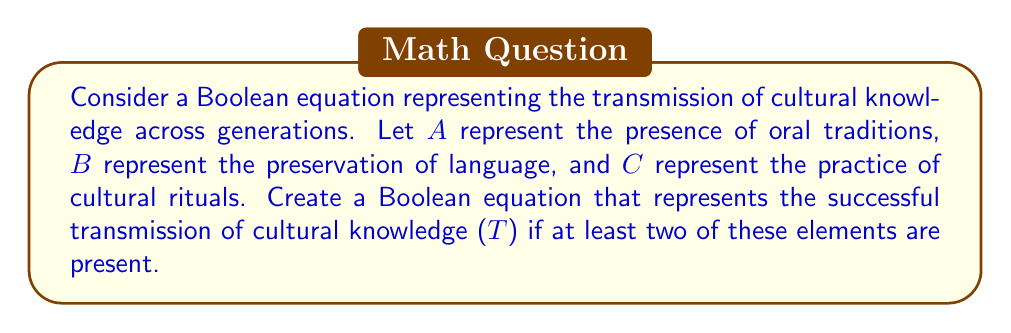What is the answer to this math problem? To solve this problem, we need to create a Boolean equation that represents the successful transmission of cultural knowledge when at least two out of three elements are present. We can approach this step-by-step:

1. First, let's consider the combinations where at least two elements are present:
   - $A$ and $B$ are present: $A \cdot B$
   - $A$ and $C$ are present: $A \cdot C$
   - $B$ and $C$ are present: $B \cdot C$
   - All three ($A$, $B$, and $C$) are present: $A \cdot B \cdot C$

2. We can combine these situations using the OR operator ($+$) since any of these combinations would result in successful transmission:

   $T = (A \cdot B) + (A \cdot C) + (B \cdot C) + (A \cdot B \cdot C)$

3. However, we can simplify this equation further. Notice that the term $(A \cdot B \cdot C)$ is redundant because it's already covered by the other terms. For example, if $A$, $B$, and $C$ are all true, then $(A \cdot B)$ is already true.

4. Therefore, our final simplified Boolean equation for the transmission of cultural knowledge is:

   $T = (A \cdot B) + (A \cdot C) + (B \cdot C)$

This equation represents that cultural knowledge is successfully transmitted ($T$ is true) if at least two out of the three elements (oral traditions, language preservation, and cultural rituals) are present.
Answer: $T = (A \cdot B) + (A \cdot C) + (B \cdot C)$ 